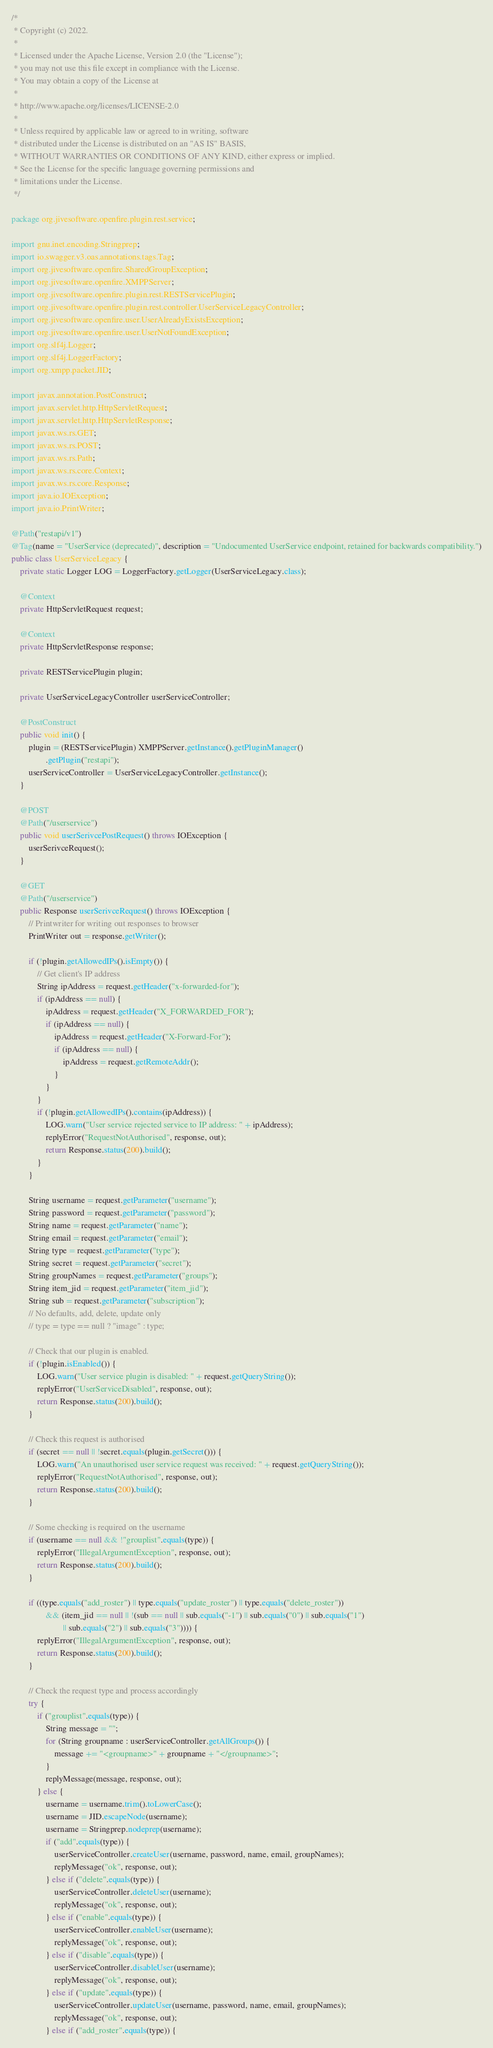Convert code to text. <code><loc_0><loc_0><loc_500><loc_500><_Java_>/*
 * Copyright (c) 2022.
 *
 * Licensed under the Apache License, Version 2.0 (the "License");
 * you may not use this file except in compliance with the License.
 * You may obtain a copy of the License at
 *
 * http://www.apache.org/licenses/LICENSE-2.0
 *
 * Unless required by applicable law or agreed to in writing, software
 * distributed under the License is distributed on an "AS IS" BASIS,
 * WITHOUT WARRANTIES OR CONDITIONS OF ANY KIND, either express or implied.
 * See the License for the specific language governing permissions and
 * limitations under the License.
 */

package org.jivesoftware.openfire.plugin.rest.service;

import gnu.inet.encoding.Stringprep;
import io.swagger.v3.oas.annotations.tags.Tag;
import org.jivesoftware.openfire.SharedGroupException;
import org.jivesoftware.openfire.XMPPServer;
import org.jivesoftware.openfire.plugin.rest.RESTServicePlugin;
import org.jivesoftware.openfire.plugin.rest.controller.UserServiceLegacyController;
import org.jivesoftware.openfire.user.UserAlreadyExistsException;
import org.jivesoftware.openfire.user.UserNotFoundException;
import org.slf4j.Logger;
import org.slf4j.LoggerFactory;
import org.xmpp.packet.JID;

import javax.annotation.PostConstruct;
import javax.servlet.http.HttpServletRequest;
import javax.servlet.http.HttpServletResponse;
import javax.ws.rs.GET;
import javax.ws.rs.POST;
import javax.ws.rs.Path;
import javax.ws.rs.core.Context;
import javax.ws.rs.core.Response;
import java.io.IOException;
import java.io.PrintWriter;

@Path("restapi/v1")
@Tag(name = "UserService (deprecated)", description = "Undocumented UserService endpoint, retained for backwards compatibility.")
public class UserServiceLegacy {
    private static Logger LOG = LoggerFactory.getLogger(UserServiceLegacy.class);

    @Context
    private HttpServletRequest request;

    @Context
    private HttpServletResponse response;

    private RESTServicePlugin plugin;

    private UserServiceLegacyController userServiceController;

    @PostConstruct
    public void init() {
        plugin = (RESTServicePlugin) XMPPServer.getInstance().getPluginManager()
                .getPlugin("restapi");
        userServiceController = UserServiceLegacyController.getInstance();
    }

    @POST
    @Path("/userservice")
    public void userSerivcePostRequest() throws IOException {
        userSerivceRequest();
    }

    @GET
    @Path("/userservice")
    public Response userSerivceRequest() throws IOException {
        // Printwriter for writing out responses to browser
        PrintWriter out = response.getWriter();

        if (!plugin.getAllowedIPs().isEmpty()) {
            // Get client's IP address
            String ipAddress = request.getHeader("x-forwarded-for");
            if (ipAddress == null) {
                ipAddress = request.getHeader("X_FORWARDED_FOR");
                if (ipAddress == null) {
                    ipAddress = request.getHeader("X-Forward-For");
                    if (ipAddress == null) {
                        ipAddress = request.getRemoteAddr();
                    }
                }
            }
            if (!plugin.getAllowedIPs().contains(ipAddress)) {
                LOG.warn("User service rejected service to IP address: " + ipAddress);
                replyError("RequestNotAuthorised", response, out);
                return Response.status(200).build();
            }
        }

        String username = request.getParameter("username");
        String password = request.getParameter("password");
        String name = request.getParameter("name");
        String email = request.getParameter("email");
        String type = request.getParameter("type");
        String secret = request.getParameter("secret");
        String groupNames = request.getParameter("groups");
        String item_jid = request.getParameter("item_jid");
        String sub = request.getParameter("subscription");
        // No defaults, add, delete, update only
        // type = type == null ? "image" : type;

        // Check that our plugin is enabled.
        if (!plugin.isEnabled()) {
            LOG.warn("User service plugin is disabled: " + request.getQueryString());
            replyError("UserServiceDisabled", response, out);
            return Response.status(200).build();
        }

        // Check this request is authorised
        if (secret == null || !secret.equals(plugin.getSecret())) {
            LOG.warn("An unauthorised user service request was received: " + request.getQueryString());
            replyError("RequestNotAuthorised", response, out);
            return Response.status(200).build();
        }

        // Some checking is required on the username
        if (username == null && !"grouplist".equals(type)) {
            replyError("IllegalArgumentException", response, out);
            return Response.status(200).build();
        }

        if ((type.equals("add_roster") || type.equals("update_roster") || type.equals("delete_roster"))
                && (item_jid == null || !(sub == null || sub.equals("-1") || sub.equals("0") || sub.equals("1")
                        || sub.equals("2") || sub.equals("3")))) {
            replyError("IllegalArgumentException", response, out);
            return Response.status(200).build();
        }

        // Check the request type and process accordingly
        try {
            if ("grouplist".equals(type)) {
                String message = "";
                for (String groupname : userServiceController.getAllGroups()) {
                    message += "<groupname>" + groupname + "</groupname>";
                }
                replyMessage(message, response, out);
            } else {
                username = username.trim().toLowerCase();
                username = JID.escapeNode(username);
                username = Stringprep.nodeprep(username);
                if ("add".equals(type)) {
                    userServiceController.createUser(username, password, name, email, groupNames);
                    replyMessage("ok", response, out);
                } else if ("delete".equals(type)) {
                    userServiceController.deleteUser(username);
                    replyMessage("ok", response, out);
                } else if ("enable".equals(type)) {
                    userServiceController.enableUser(username);
                    replyMessage("ok", response, out);
                } else if ("disable".equals(type)) {
                    userServiceController.disableUser(username);
                    replyMessage("ok", response, out);
                } else if ("update".equals(type)) {
                    userServiceController.updateUser(username, password, name, email, groupNames);
                    replyMessage("ok", response, out);
                } else if ("add_roster".equals(type)) {</code> 